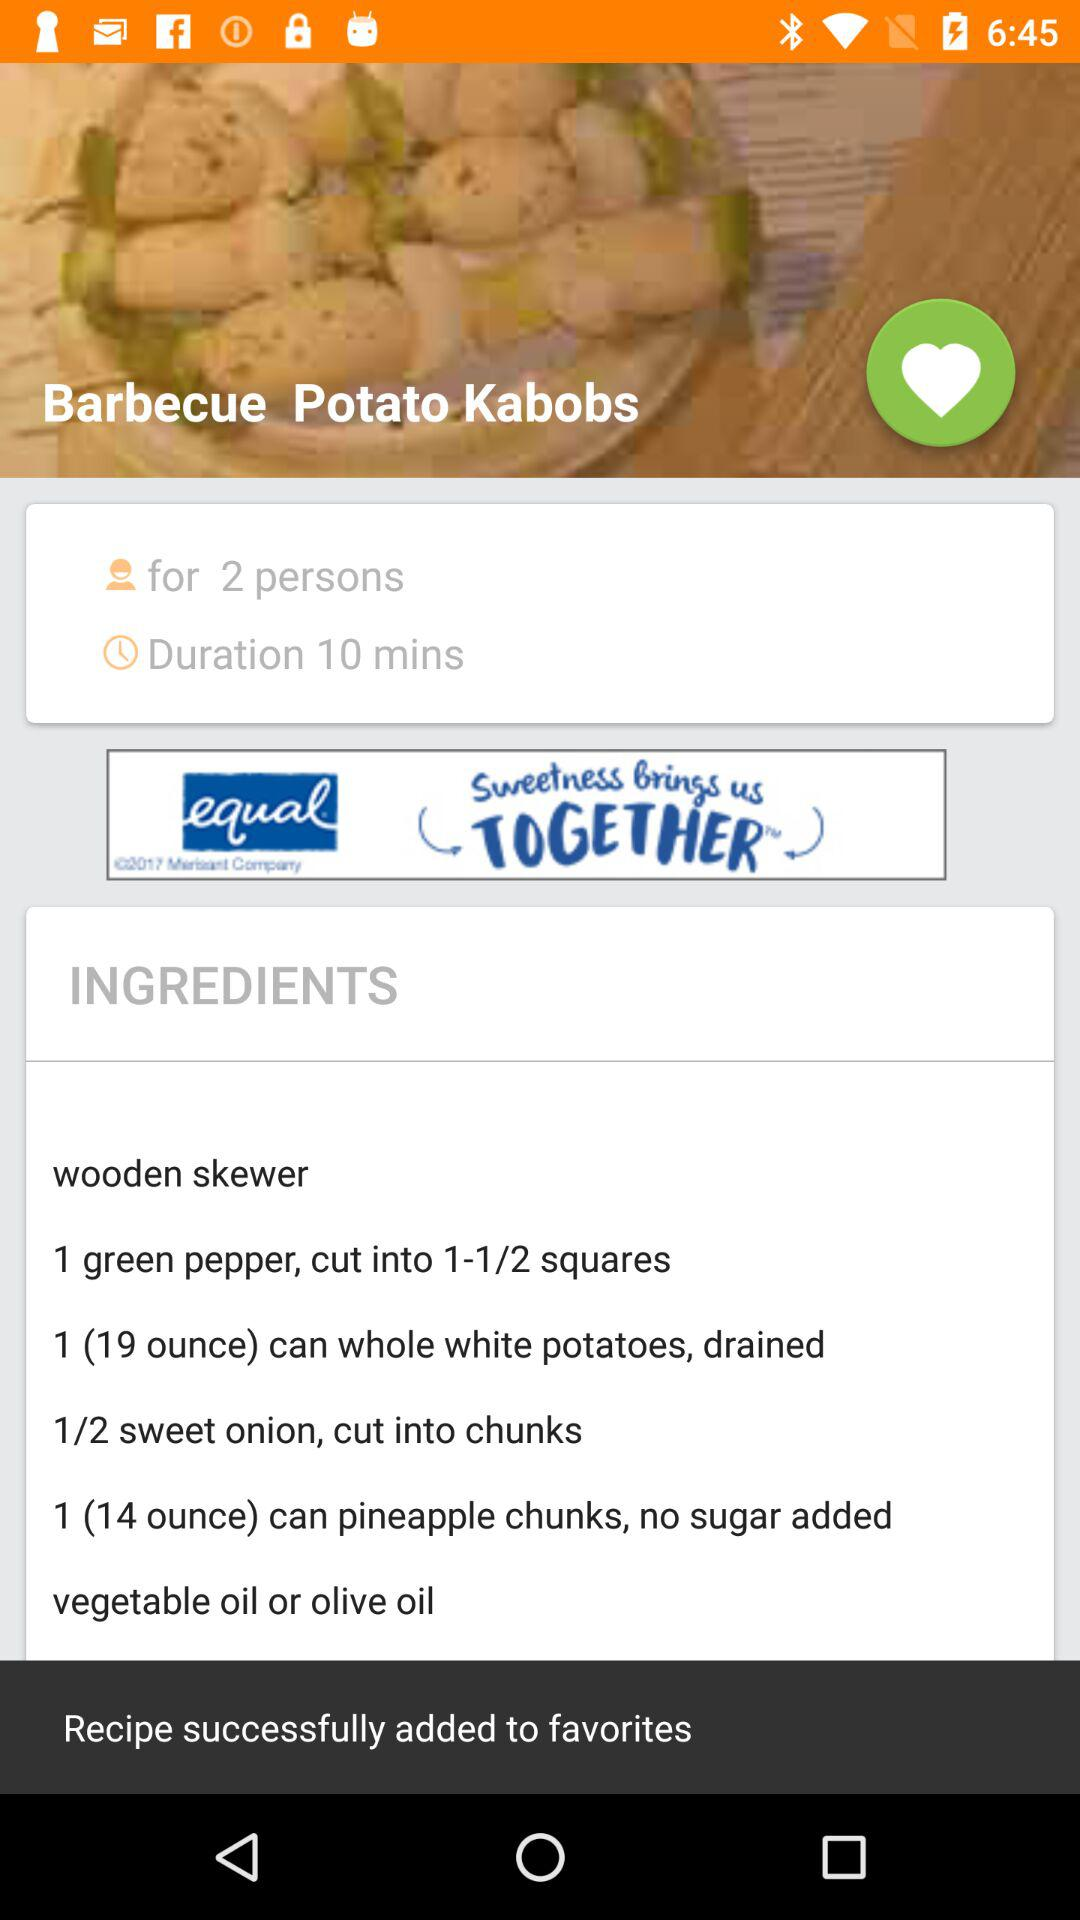Which oil can be used in Barbecue Potato Kabobs? You can use vegetable oil or olive oil. 